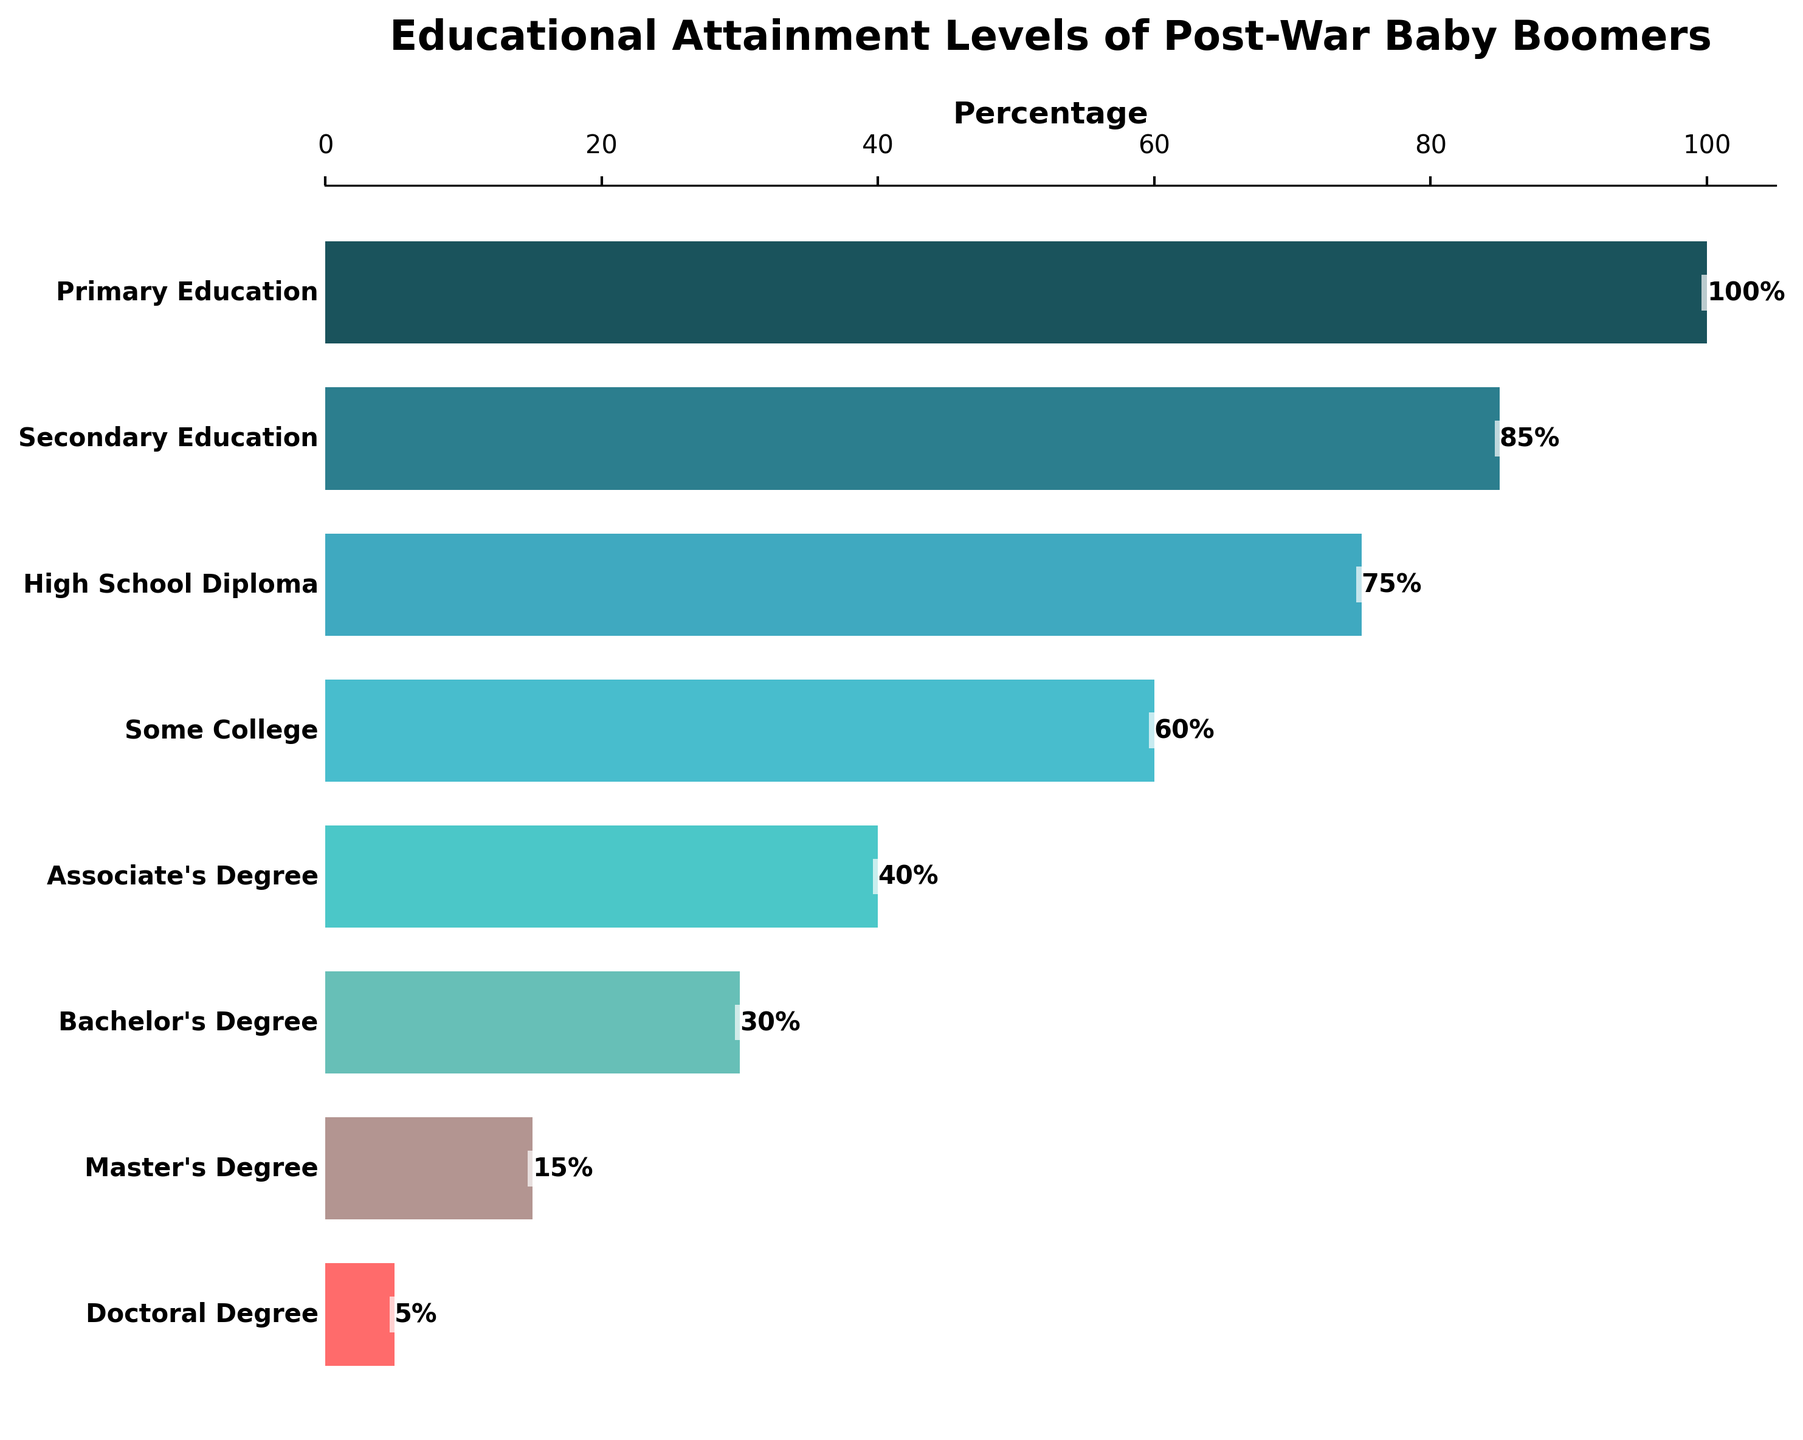What is the title of the figure? The title of the figure is found at the top, where it's prominently displayed.
Answer: Educational Attainment Levels of Post-War Baby Boomers What percentage of post-war baby boomers achieved a Bachelor's Degree? Look at the bar associated with the Bachelor's Degree on the y-axis and find its percentage value on the x-axis.
Answer: 30% By how much did the percentage decrease from those who completed High School Diploma to those who reached a Bachelor's Degree? Identify the percentages for High School Diploma (75%) and Bachelor's Degree (30%), then calculate the difference: 75% - 30%.
Answer: 45% Which educational attainment level has the lowest percentage of post-war baby boomers? Look at the smallest value on the x-axis and find the corresponding education level on the y-axis.
Answer: Doctoral Degree What is the difference in percentage between those with a Master's Degree and those with an Associate's Degree? Identify the percentages for Master's Degree (15%) and Associate's Degree (40%) and subtract the Master's percentage from the Associate's percentage: 40% - 15%.
Answer: 25% How many educational levels are represented in this figure? Count the number of different education levels listed on the y-axis.
Answer: 8 What proportion of post-war baby boomers completed some form of tertiary education (Associate's Degree and higher)? Sum the percentages of the Associate's Degree (40%), Bachelor's Degree (30%), Master's Degree (15%), and Doctoral Degree (5%): 40% + 30% + 15% + 5%.
Answer: 90% Which educational attainment level saw a decrease in percentage of less than 10% compared to the previous level? Compare the percentages of consecutive education levels and find the pair that has a difference of less than 10%.
Answer: Secondary Education to High School Diploma What percentage of post-war baby boomers stopped their education after Secondary Education? Identify the percentage associated with Secondary Education and compare it to the next level, High School Diploma. The question implies that those who didn't continue are 85% - 75%.
Answer: 10% How does the decline in percentage from Primary Education to High School Diploma compare to the decline from High School Diploma to Doctoral Degree? Calculate the decline from Primary to High School Diploma: 100% - 75% = 25%. Then from High School Diploma to Doctoral Degree (75% - 5% = 70%). Compare these two values.
Answer: The decline from High School Diploma to Doctoral Degree (70%) is greater than from Primary Education to High School Diploma (25%) 